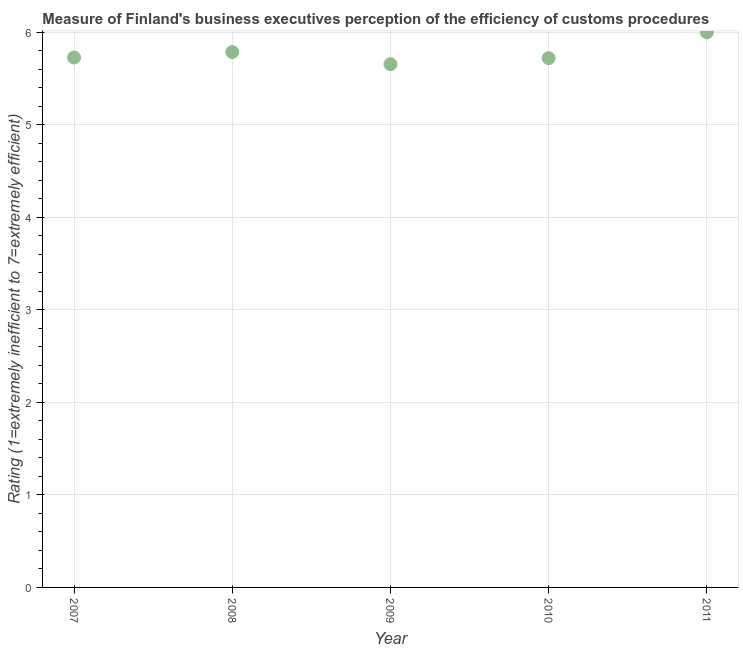What is the rating measuring burden of customs procedure in 2007?
Offer a terse response. 5.73. Across all years, what is the maximum rating measuring burden of customs procedure?
Make the answer very short. 6. Across all years, what is the minimum rating measuring burden of customs procedure?
Your answer should be very brief. 5.66. In which year was the rating measuring burden of customs procedure maximum?
Your response must be concise. 2011. In which year was the rating measuring burden of customs procedure minimum?
Offer a very short reply. 2009. What is the sum of the rating measuring burden of customs procedure?
Offer a terse response. 28.9. What is the difference between the rating measuring burden of customs procedure in 2009 and 2010?
Offer a terse response. -0.07. What is the average rating measuring burden of customs procedure per year?
Your response must be concise. 5.78. What is the median rating measuring burden of customs procedure?
Your response must be concise. 5.73. In how many years, is the rating measuring burden of customs procedure greater than 3.4 ?
Keep it short and to the point. 5. What is the ratio of the rating measuring burden of customs procedure in 2007 to that in 2009?
Provide a succinct answer. 1.01. Is the rating measuring burden of customs procedure in 2007 less than that in 2009?
Your answer should be compact. No. What is the difference between the highest and the second highest rating measuring burden of customs procedure?
Ensure brevity in your answer.  0.21. Is the sum of the rating measuring burden of customs procedure in 2008 and 2011 greater than the maximum rating measuring burden of customs procedure across all years?
Keep it short and to the point. Yes. What is the difference between the highest and the lowest rating measuring burden of customs procedure?
Offer a very short reply. 0.34. How many dotlines are there?
Keep it short and to the point. 1. How many years are there in the graph?
Provide a short and direct response. 5. What is the difference between two consecutive major ticks on the Y-axis?
Give a very brief answer. 1. What is the title of the graph?
Keep it short and to the point. Measure of Finland's business executives perception of the efficiency of customs procedures. What is the label or title of the X-axis?
Provide a short and direct response. Year. What is the label or title of the Y-axis?
Offer a terse response. Rating (1=extremely inefficient to 7=extremely efficient). What is the Rating (1=extremely inefficient to 7=extremely efficient) in 2007?
Offer a very short reply. 5.73. What is the Rating (1=extremely inefficient to 7=extremely efficient) in 2008?
Your answer should be very brief. 5.79. What is the Rating (1=extremely inefficient to 7=extremely efficient) in 2009?
Your answer should be compact. 5.66. What is the Rating (1=extremely inefficient to 7=extremely efficient) in 2010?
Your answer should be very brief. 5.72. What is the Rating (1=extremely inefficient to 7=extremely efficient) in 2011?
Your response must be concise. 6. What is the difference between the Rating (1=extremely inefficient to 7=extremely efficient) in 2007 and 2008?
Your answer should be compact. -0.06. What is the difference between the Rating (1=extremely inefficient to 7=extremely efficient) in 2007 and 2009?
Your response must be concise. 0.07. What is the difference between the Rating (1=extremely inefficient to 7=extremely efficient) in 2007 and 2010?
Provide a succinct answer. 0.01. What is the difference between the Rating (1=extremely inefficient to 7=extremely efficient) in 2007 and 2011?
Provide a succinct answer. -0.27. What is the difference between the Rating (1=extremely inefficient to 7=extremely efficient) in 2008 and 2009?
Your answer should be compact. 0.13. What is the difference between the Rating (1=extremely inefficient to 7=extremely efficient) in 2008 and 2010?
Ensure brevity in your answer.  0.07. What is the difference between the Rating (1=extremely inefficient to 7=extremely efficient) in 2008 and 2011?
Offer a terse response. -0.21. What is the difference between the Rating (1=extremely inefficient to 7=extremely efficient) in 2009 and 2010?
Your answer should be very brief. -0.07. What is the difference between the Rating (1=extremely inefficient to 7=extremely efficient) in 2009 and 2011?
Provide a succinct answer. -0.34. What is the difference between the Rating (1=extremely inefficient to 7=extremely efficient) in 2010 and 2011?
Offer a terse response. -0.28. What is the ratio of the Rating (1=extremely inefficient to 7=extremely efficient) in 2007 to that in 2009?
Offer a terse response. 1.01. What is the ratio of the Rating (1=extremely inefficient to 7=extremely efficient) in 2007 to that in 2010?
Ensure brevity in your answer.  1. What is the ratio of the Rating (1=extremely inefficient to 7=extremely efficient) in 2007 to that in 2011?
Make the answer very short. 0.95. What is the ratio of the Rating (1=extremely inefficient to 7=extremely efficient) in 2008 to that in 2010?
Keep it short and to the point. 1.01. What is the ratio of the Rating (1=extremely inefficient to 7=extremely efficient) in 2008 to that in 2011?
Ensure brevity in your answer.  0.96. What is the ratio of the Rating (1=extremely inefficient to 7=extremely efficient) in 2009 to that in 2010?
Ensure brevity in your answer.  0.99. What is the ratio of the Rating (1=extremely inefficient to 7=extremely efficient) in 2009 to that in 2011?
Provide a short and direct response. 0.94. What is the ratio of the Rating (1=extremely inefficient to 7=extremely efficient) in 2010 to that in 2011?
Your answer should be compact. 0.95. 